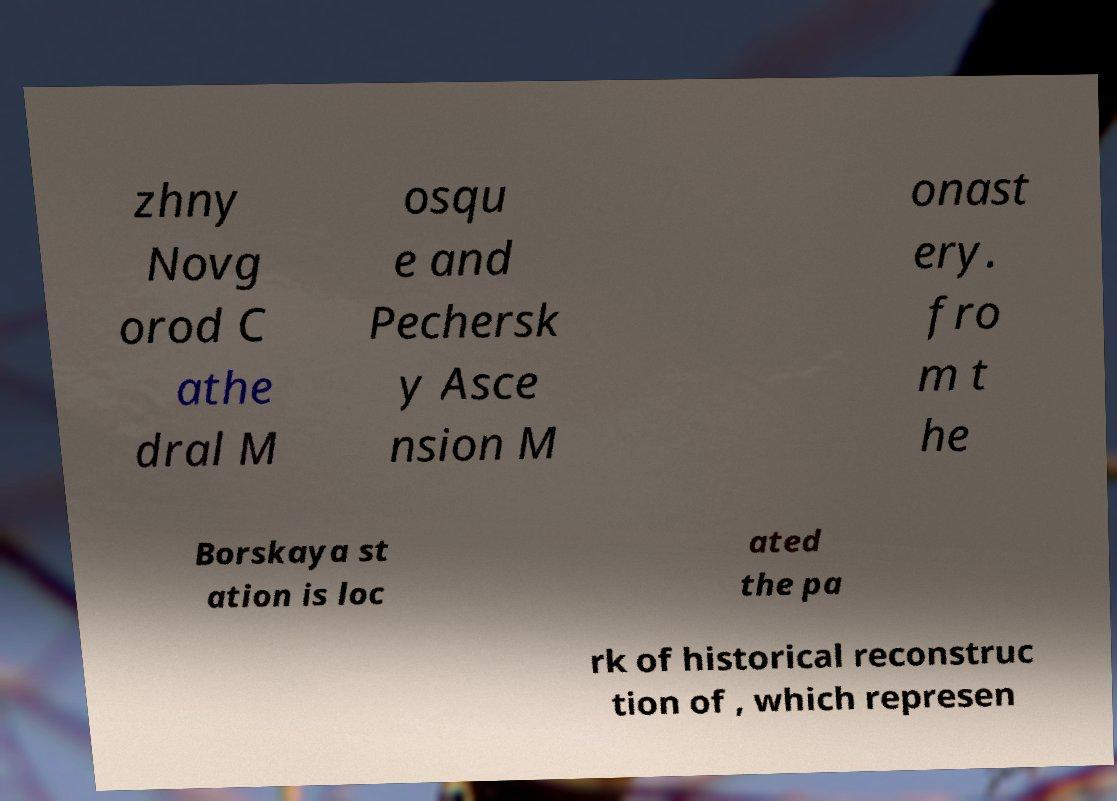Can you read and provide the text displayed in the image?This photo seems to have some interesting text. Can you extract and type it out for me? zhny Novg orod C athe dral M osqu e and Pechersk y Asce nsion M onast ery. fro m t he Borskaya st ation is loc ated the pa rk of historical reconstruc tion of , which represen 